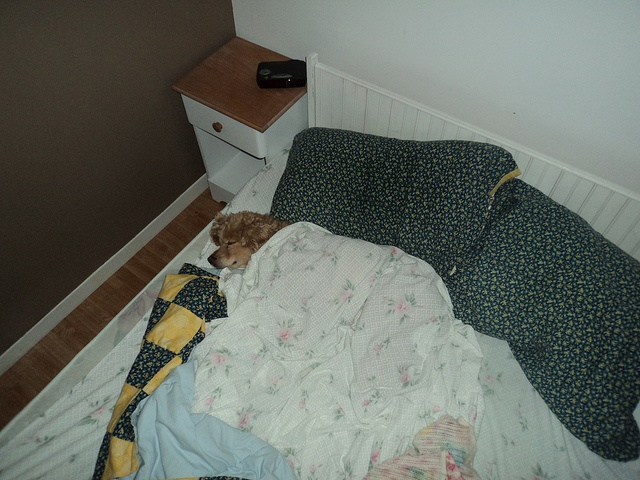Describe the objects in this image and their specific colors. I can see bed in black, darkgray, and gray tones, dog in black, maroon, and gray tones, and clock in black and gray tones in this image. 